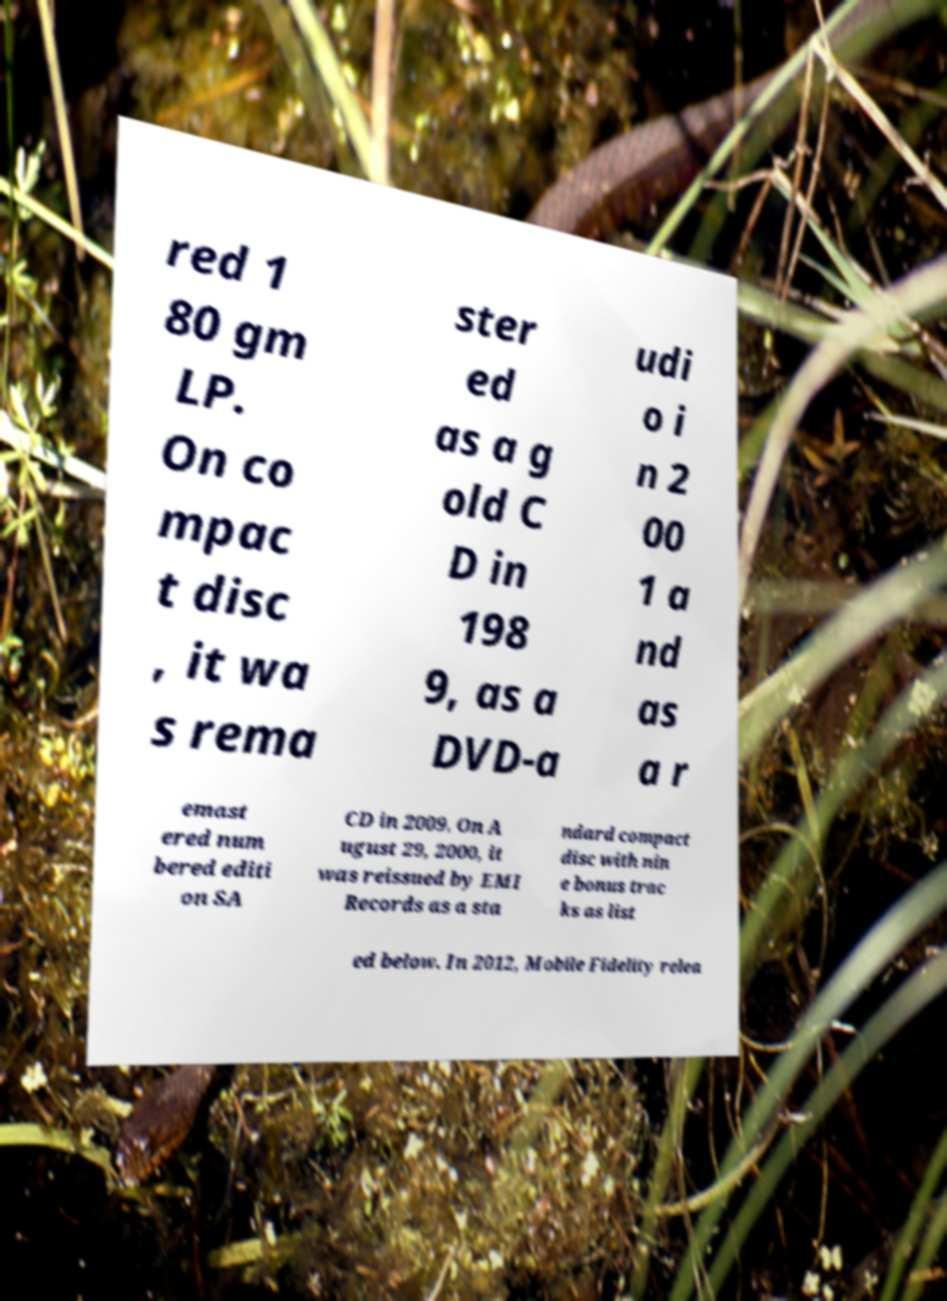Can you accurately transcribe the text from the provided image for me? red 1 80 gm LP. On co mpac t disc , it wa s rema ster ed as a g old C D in 198 9, as a DVD-a udi o i n 2 00 1 a nd as a r emast ered num bered editi on SA CD in 2009. On A ugust 29, 2000, it was reissued by EMI Records as a sta ndard compact disc with nin e bonus trac ks as list ed below. In 2012, Mobile Fidelity relea 